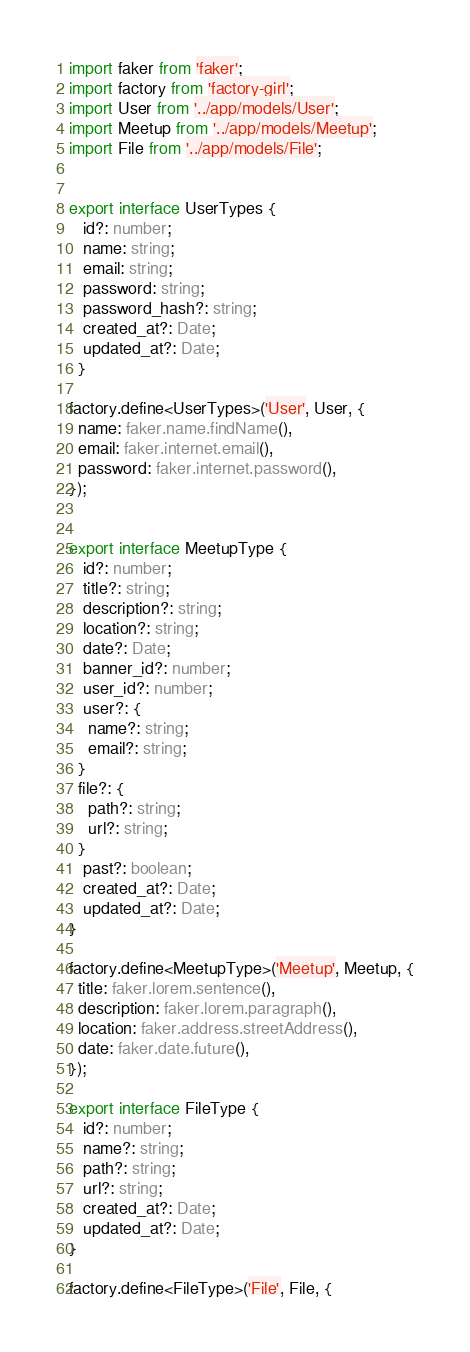<code> <loc_0><loc_0><loc_500><loc_500><_TypeScript_>import faker from 'faker';
import factory from 'factory-girl';
import User from '../app/models/User';
import Meetup from '../app/models/Meetup';
import File from '../app/models/File';


export interface UserTypes {
   id?: number;
   name: string;
   email: string;
   password: string;
   password_hash?: string;
   created_at?: Date;
   updated_at?: Date;
  }

factory.define<UserTypes>('User', User, {
  name: faker.name.findName(),
  email: faker.internet.email(),
  password: faker.internet.password(),
});


export interface MeetupType {
   id?: number;
   title?: string;
   description?: string;
   location?: string;
   date?: Date;
   banner_id?: number;
   user_id?: number;
   user?: {
    name?: string;
    email?: string;
  }
  file?: {
    path?: string;
    url?: string;
  }
   past?: boolean;
   created_at?: Date;
   updated_at?: Date;
}

factory.define<MeetupType>('Meetup', Meetup, {
  title: faker.lorem.sentence(),
  description: faker.lorem.paragraph(),
  location: faker.address.streetAddress(),
  date: faker.date.future(),
});

export interface FileType {
   id?: number;
   name?: string;
   path?: string;
   url?: string;
   created_at?: Date;
   updated_at?: Date;
}

factory.define<FileType>('File', File, {</code> 